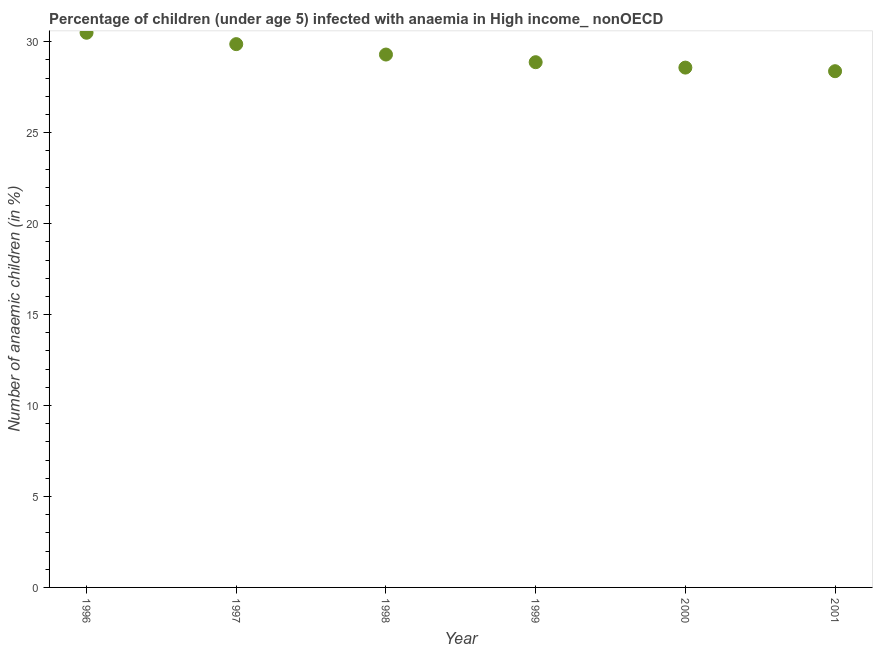What is the number of anaemic children in 1998?
Your answer should be compact. 29.3. Across all years, what is the maximum number of anaemic children?
Provide a short and direct response. 30.5. Across all years, what is the minimum number of anaemic children?
Offer a terse response. 28.38. In which year was the number of anaemic children maximum?
Your answer should be very brief. 1996. What is the sum of the number of anaemic children?
Keep it short and to the point. 175.51. What is the difference between the number of anaemic children in 1999 and 2000?
Your response must be concise. 0.3. What is the average number of anaemic children per year?
Give a very brief answer. 29.25. What is the median number of anaemic children?
Provide a succinct answer. 29.09. In how many years, is the number of anaemic children greater than 25 %?
Your response must be concise. 6. What is the ratio of the number of anaemic children in 1997 to that in 1998?
Make the answer very short. 1.02. Is the number of anaemic children in 1996 less than that in 1997?
Make the answer very short. No. Is the difference between the number of anaemic children in 1996 and 1999 greater than the difference between any two years?
Offer a terse response. No. What is the difference between the highest and the second highest number of anaemic children?
Keep it short and to the point. 0.63. Is the sum of the number of anaemic children in 1997 and 1999 greater than the maximum number of anaemic children across all years?
Offer a very short reply. Yes. What is the difference between the highest and the lowest number of anaemic children?
Provide a succinct answer. 2.11. In how many years, is the number of anaemic children greater than the average number of anaemic children taken over all years?
Ensure brevity in your answer.  3. Does the number of anaemic children monotonically increase over the years?
Keep it short and to the point. No. How many dotlines are there?
Your answer should be very brief. 1. How many years are there in the graph?
Your response must be concise. 6. What is the difference between two consecutive major ticks on the Y-axis?
Your response must be concise. 5. Are the values on the major ticks of Y-axis written in scientific E-notation?
Offer a very short reply. No. What is the title of the graph?
Provide a short and direct response. Percentage of children (under age 5) infected with anaemia in High income_ nonOECD. What is the label or title of the Y-axis?
Ensure brevity in your answer.  Number of anaemic children (in %). What is the Number of anaemic children (in %) in 1996?
Offer a very short reply. 30.5. What is the Number of anaemic children (in %) in 1997?
Provide a succinct answer. 29.87. What is the Number of anaemic children (in %) in 1998?
Give a very brief answer. 29.3. What is the Number of anaemic children (in %) in 1999?
Offer a terse response. 28.88. What is the Number of anaemic children (in %) in 2000?
Your answer should be very brief. 28.58. What is the Number of anaemic children (in %) in 2001?
Provide a short and direct response. 28.38. What is the difference between the Number of anaemic children (in %) in 1996 and 1997?
Your answer should be very brief. 0.63. What is the difference between the Number of anaemic children (in %) in 1996 and 1998?
Your response must be concise. 1.2. What is the difference between the Number of anaemic children (in %) in 1996 and 1999?
Your answer should be very brief. 1.62. What is the difference between the Number of anaemic children (in %) in 1996 and 2000?
Ensure brevity in your answer.  1.92. What is the difference between the Number of anaemic children (in %) in 1996 and 2001?
Keep it short and to the point. 2.11. What is the difference between the Number of anaemic children (in %) in 1997 and 1998?
Your response must be concise. 0.57. What is the difference between the Number of anaemic children (in %) in 1997 and 1999?
Provide a short and direct response. 0.99. What is the difference between the Number of anaemic children (in %) in 1997 and 2000?
Your answer should be very brief. 1.29. What is the difference between the Number of anaemic children (in %) in 1997 and 2001?
Give a very brief answer. 1.49. What is the difference between the Number of anaemic children (in %) in 1998 and 1999?
Provide a succinct answer. 0.42. What is the difference between the Number of anaemic children (in %) in 1998 and 2000?
Your response must be concise. 0.72. What is the difference between the Number of anaemic children (in %) in 1998 and 2001?
Provide a succinct answer. 0.92. What is the difference between the Number of anaemic children (in %) in 1999 and 2000?
Offer a terse response. 0.3. What is the difference between the Number of anaemic children (in %) in 1999 and 2001?
Make the answer very short. 0.49. What is the difference between the Number of anaemic children (in %) in 2000 and 2001?
Ensure brevity in your answer.  0.2. What is the ratio of the Number of anaemic children (in %) in 1996 to that in 1998?
Ensure brevity in your answer.  1.04. What is the ratio of the Number of anaemic children (in %) in 1996 to that in 1999?
Your answer should be very brief. 1.06. What is the ratio of the Number of anaemic children (in %) in 1996 to that in 2000?
Offer a very short reply. 1.07. What is the ratio of the Number of anaemic children (in %) in 1996 to that in 2001?
Your answer should be very brief. 1.07. What is the ratio of the Number of anaemic children (in %) in 1997 to that in 1998?
Provide a succinct answer. 1.02. What is the ratio of the Number of anaemic children (in %) in 1997 to that in 1999?
Your response must be concise. 1.03. What is the ratio of the Number of anaemic children (in %) in 1997 to that in 2000?
Your answer should be compact. 1.04. What is the ratio of the Number of anaemic children (in %) in 1997 to that in 2001?
Your answer should be very brief. 1.05. What is the ratio of the Number of anaemic children (in %) in 1998 to that in 2000?
Give a very brief answer. 1.02. What is the ratio of the Number of anaemic children (in %) in 1998 to that in 2001?
Make the answer very short. 1.03. What is the ratio of the Number of anaemic children (in %) in 2000 to that in 2001?
Your response must be concise. 1.01. 